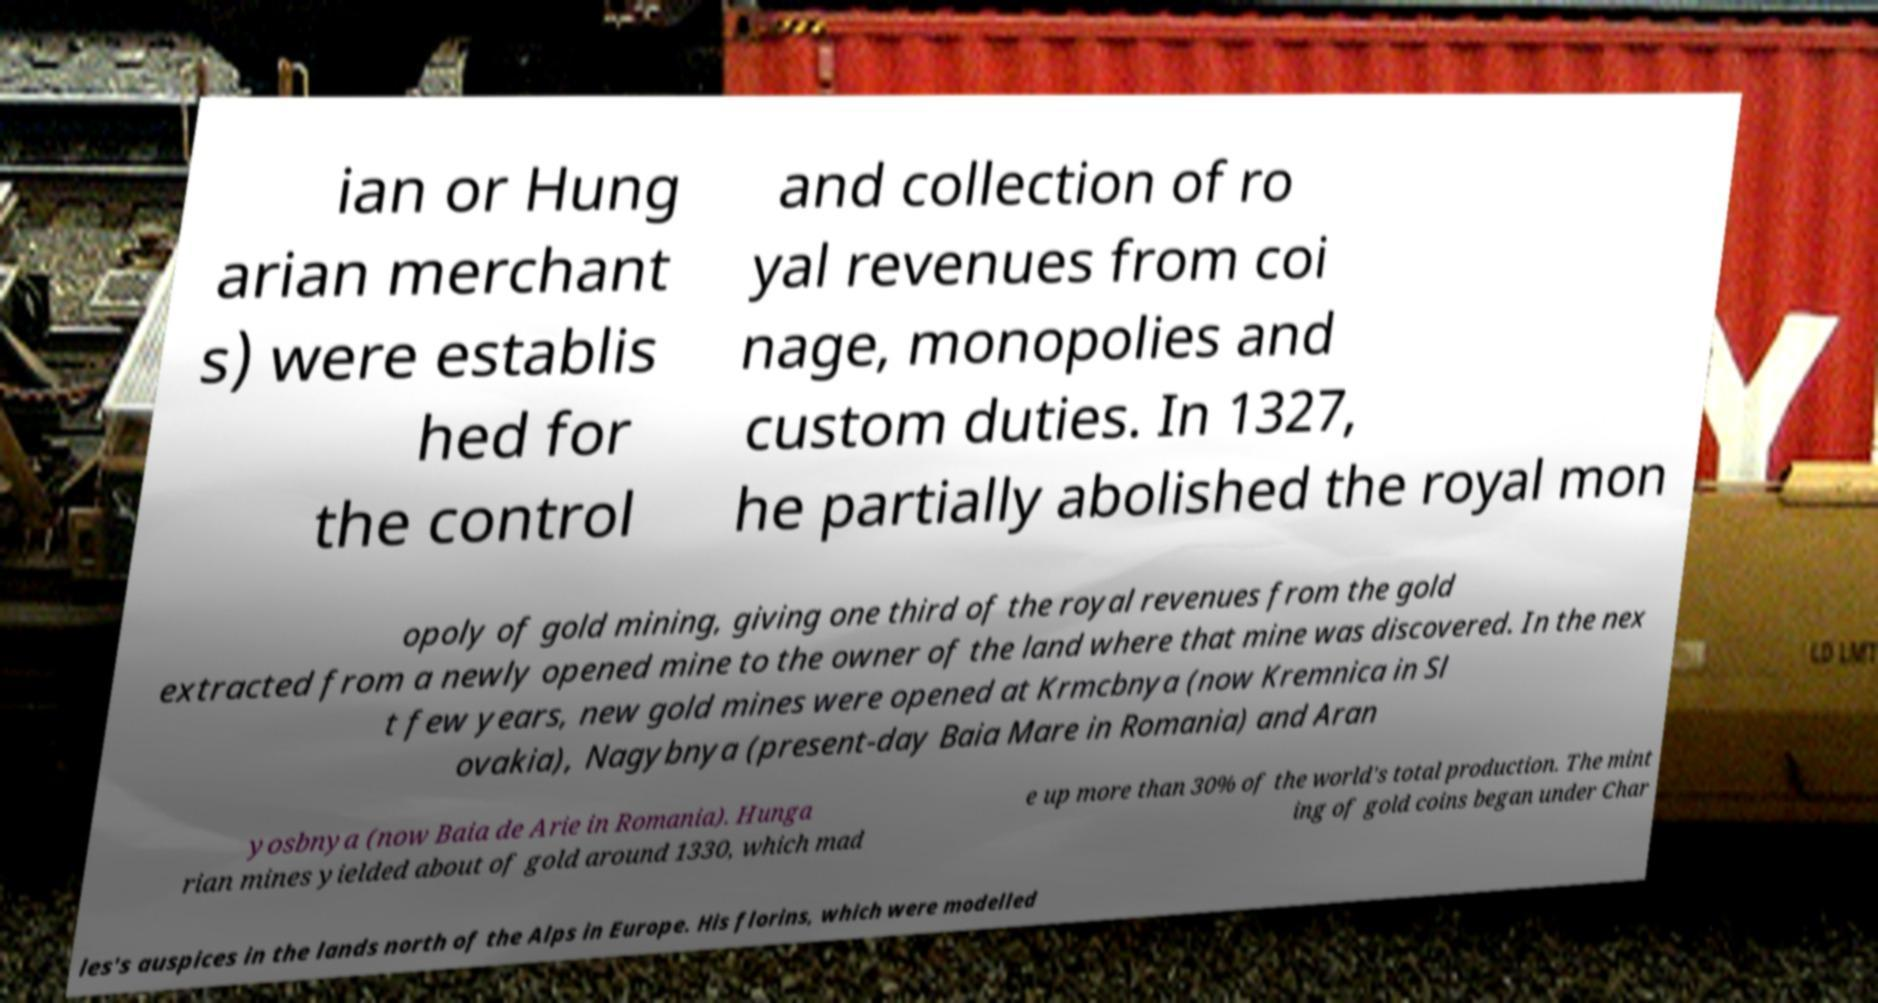I need the written content from this picture converted into text. Can you do that? ian or Hung arian merchant s) were establis hed for the control and collection of ro yal revenues from coi nage, monopolies and custom duties. In 1327, he partially abolished the royal mon opoly of gold mining, giving one third of the royal revenues from the gold extracted from a newly opened mine to the owner of the land where that mine was discovered. In the nex t few years, new gold mines were opened at Krmcbnya (now Kremnica in Sl ovakia), Nagybnya (present-day Baia Mare in Romania) and Aran yosbnya (now Baia de Arie in Romania). Hunga rian mines yielded about of gold around 1330, which mad e up more than 30% of the world's total production. The mint ing of gold coins began under Char les's auspices in the lands north of the Alps in Europe. His florins, which were modelled 